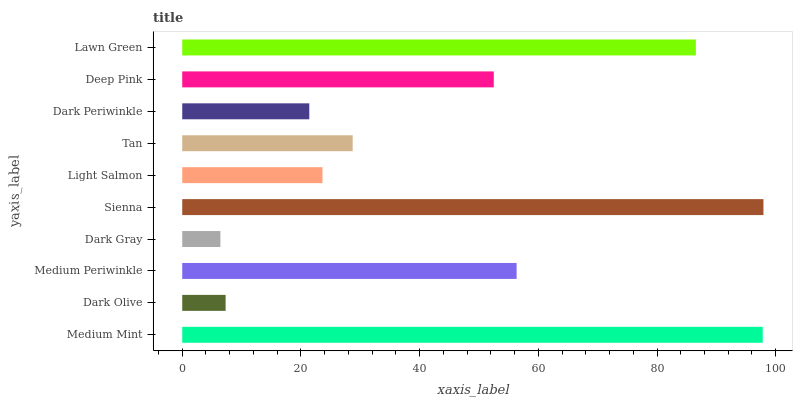Is Dark Gray the minimum?
Answer yes or no. Yes. Is Sienna the maximum?
Answer yes or no. Yes. Is Dark Olive the minimum?
Answer yes or no. No. Is Dark Olive the maximum?
Answer yes or no. No. Is Medium Mint greater than Dark Olive?
Answer yes or no. Yes. Is Dark Olive less than Medium Mint?
Answer yes or no. Yes. Is Dark Olive greater than Medium Mint?
Answer yes or no. No. Is Medium Mint less than Dark Olive?
Answer yes or no. No. Is Deep Pink the high median?
Answer yes or no. Yes. Is Tan the low median?
Answer yes or no. Yes. Is Lawn Green the high median?
Answer yes or no. No. Is Medium Periwinkle the low median?
Answer yes or no. No. 